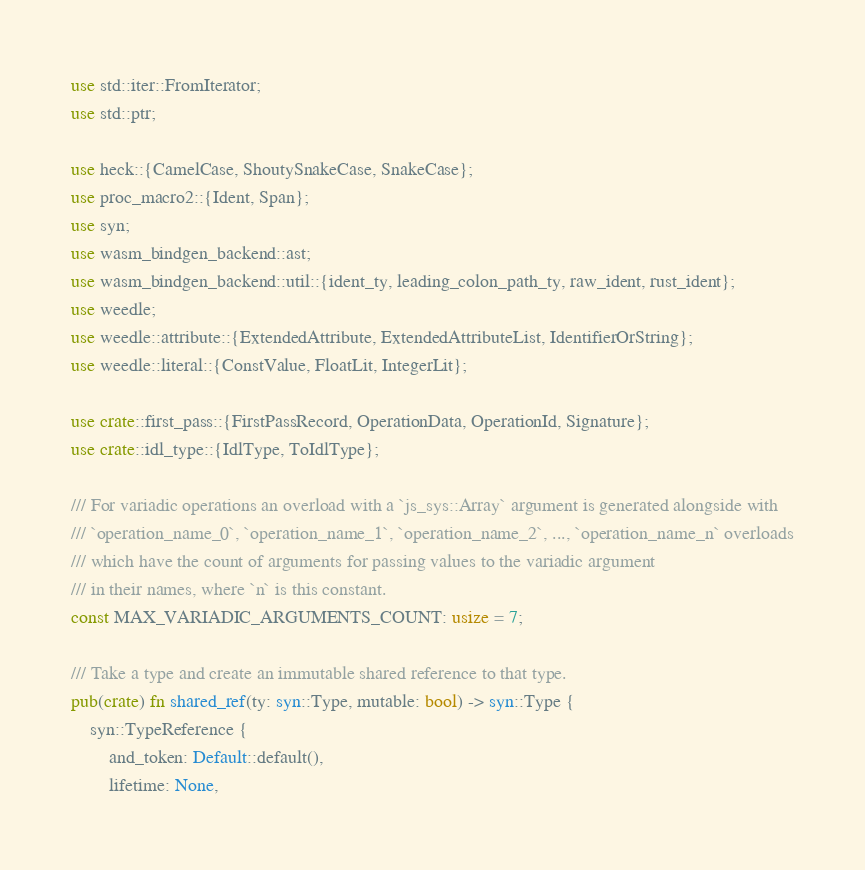<code> <loc_0><loc_0><loc_500><loc_500><_Rust_>use std::iter::FromIterator;
use std::ptr;

use heck::{CamelCase, ShoutySnakeCase, SnakeCase};
use proc_macro2::{Ident, Span};
use syn;
use wasm_bindgen_backend::ast;
use wasm_bindgen_backend::util::{ident_ty, leading_colon_path_ty, raw_ident, rust_ident};
use weedle;
use weedle::attribute::{ExtendedAttribute, ExtendedAttributeList, IdentifierOrString};
use weedle::literal::{ConstValue, FloatLit, IntegerLit};

use crate::first_pass::{FirstPassRecord, OperationData, OperationId, Signature};
use crate::idl_type::{IdlType, ToIdlType};

/// For variadic operations an overload with a `js_sys::Array` argument is generated alongside with
/// `operation_name_0`, `operation_name_1`, `operation_name_2`, ..., `operation_name_n` overloads
/// which have the count of arguments for passing values to the variadic argument
/// in their names, where `n` is this constant.
const MAX_VARIADIC_ARGUMENTS_COUNT: usize = 7;

/// Take a type and create an immutable shared reference to that type.
pub(crate) fn shared_ref(ty: syn::Type, mutable: bool) -> syn::Type {
    syn::TypeReference {
        and_token: Default::default(),
        lifetime: None,</code> 